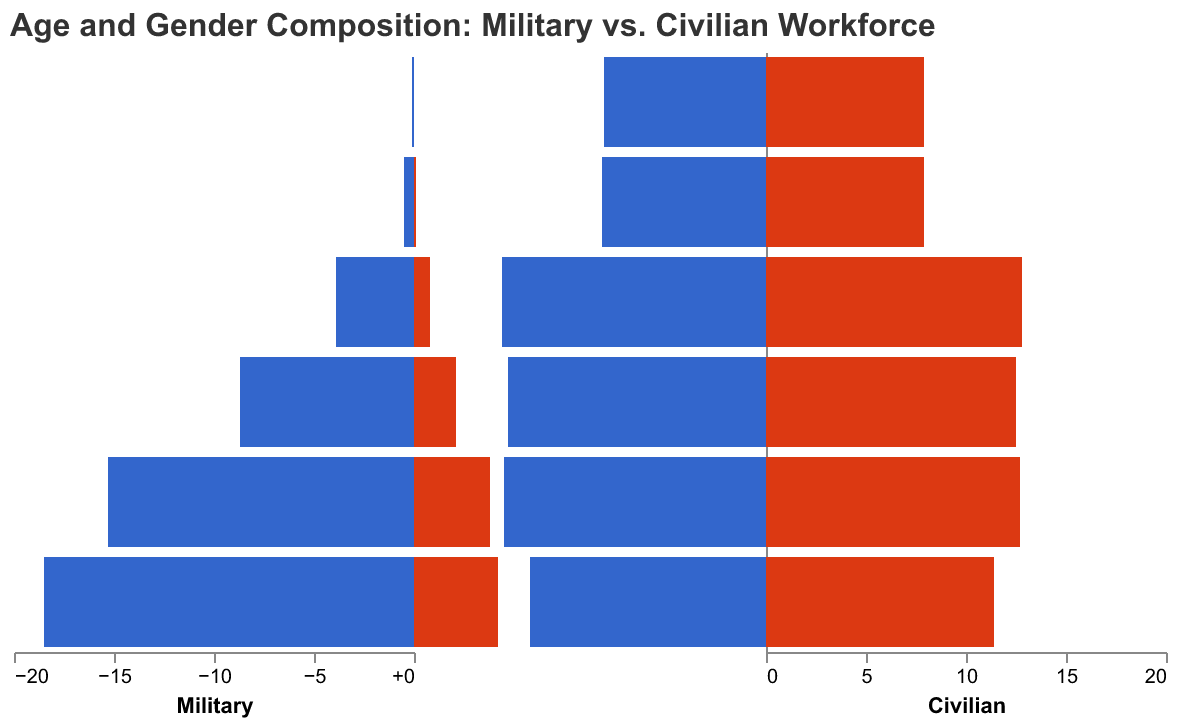Which age group has the highest percentage of military males? The bar on the left side (Military) for males in the "18-24" age group is the longest, indicating that this group has the highest percentage.
Answer: 18-24 How does the percentage of military females in the 25-34 age group compare to the percentage of civilian females in the same age group? The bar on the right side (Civilian) for females in the "25-34" age group is longer than the corresponding bar on the left side (Military), indicating that the percentage of civilian females is higher.
Answer: Civilian females have a higher percentage Compare the percentage of civilian males to civilian females in the 45-54 age group. The bar for civilian males in the "45-54" age group is slightly longer than the bar for civilian females, indicating that the percentage of males is higher.
Answer: Civilian males have a higher percentage What is the combined percentage of military personnel (both genders) in the 35-44 age group? The bars representing military males and females (8.7% + 2.1%) should be summed up.
Answer: 10.8% Which gender shows a more significant drop in military personnel percentages from the 25-34 age group to the 35-44 age group? The difference in the bar length for military males is 15.3% - 8.7% = 6.6%, while for military females it is 3.8% - 2.1% = 1.7%. Hence, the drop is more significant for military males.
Answer: Military males In the 55-64 age group, what is the approximate ratio between the percentage of civilian males and military males? The percentage of civilian males is 11.8% and military males is 0.5%. The ratio can be calculated as 11.8 / 0.5 = 23.6.
Answer: ~24:1 Which age group has the least number of military females? By observing the shortest bar for military females across all age groups on the left side of the pyramid, the "65+" group has the least number of military females.
Answer: 65+ What is the trend in the percentage of military males as age increases? As age increases from 18-24 to 65+, the length of the bars for military males consistently decreases.
Answer: Decreasing Are there more civilian females or civilian males in the 65+ age group? By observing the bars on the right side for the "65+" age group, both civilian males and civilian females have bars of almost the same length, but the bar for males appears slightly longer.
Answer: Civilian males 